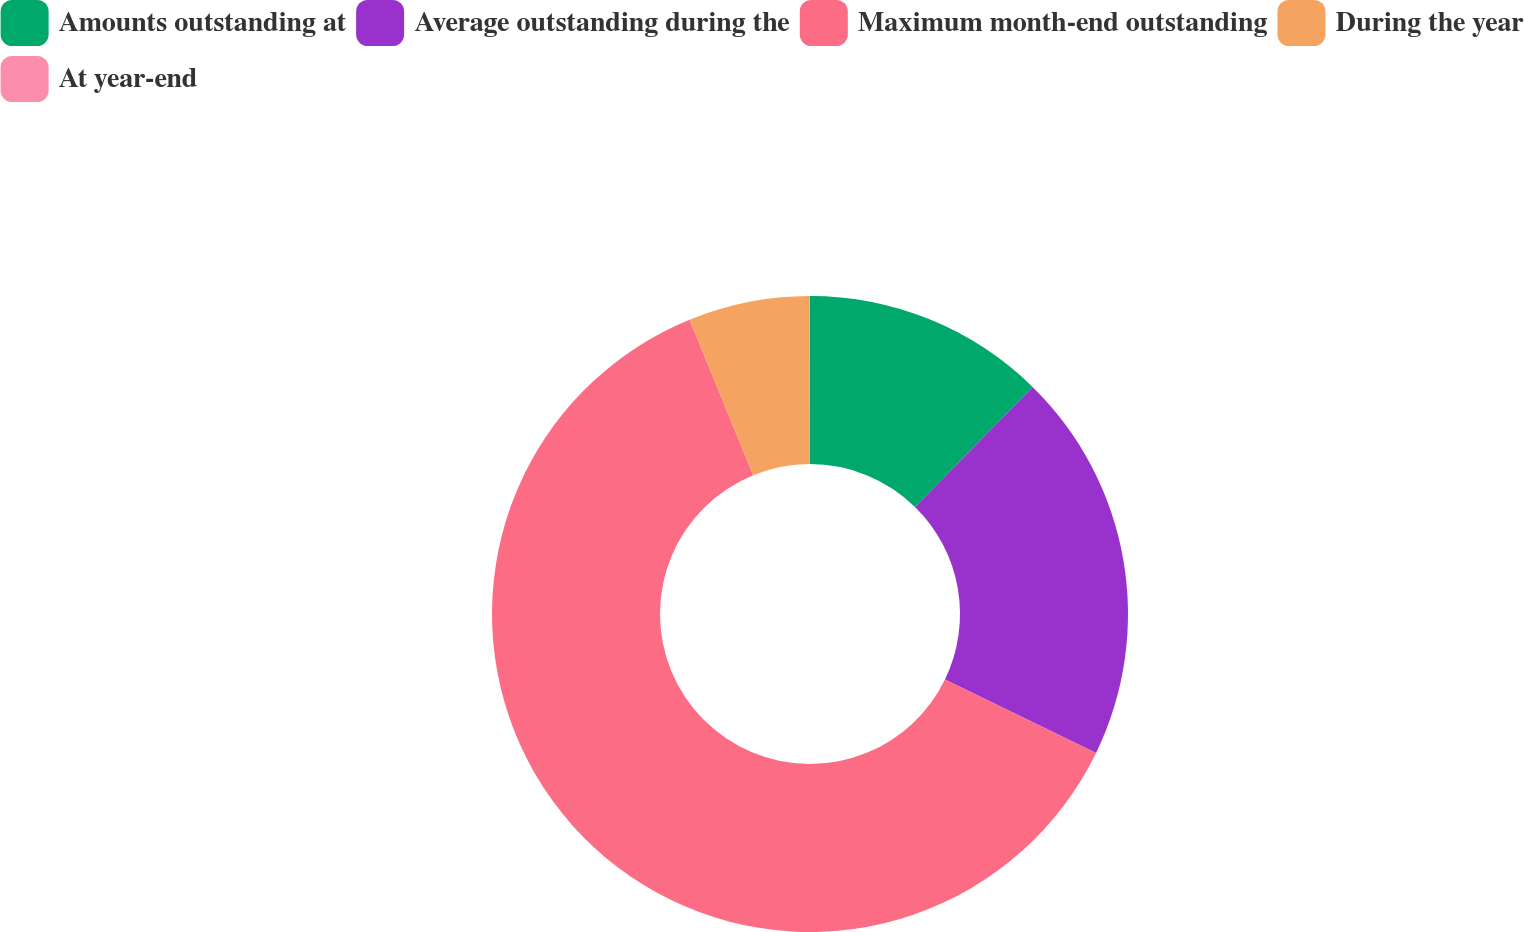Convert chart. <chart><loc_0><loc_0><loc_500><loc_500><pie_chart><fcel>Amounts outstanding at<fcel>Average outstanding during the<fcel>Maximum month-end outstanding<fcel>During the year<fcel>At year-end<nl><fcel>12.34%<fcel>19.85%<fcel>61.62%<fcel>6.17%<fcel>0.01%<nl></chart> 